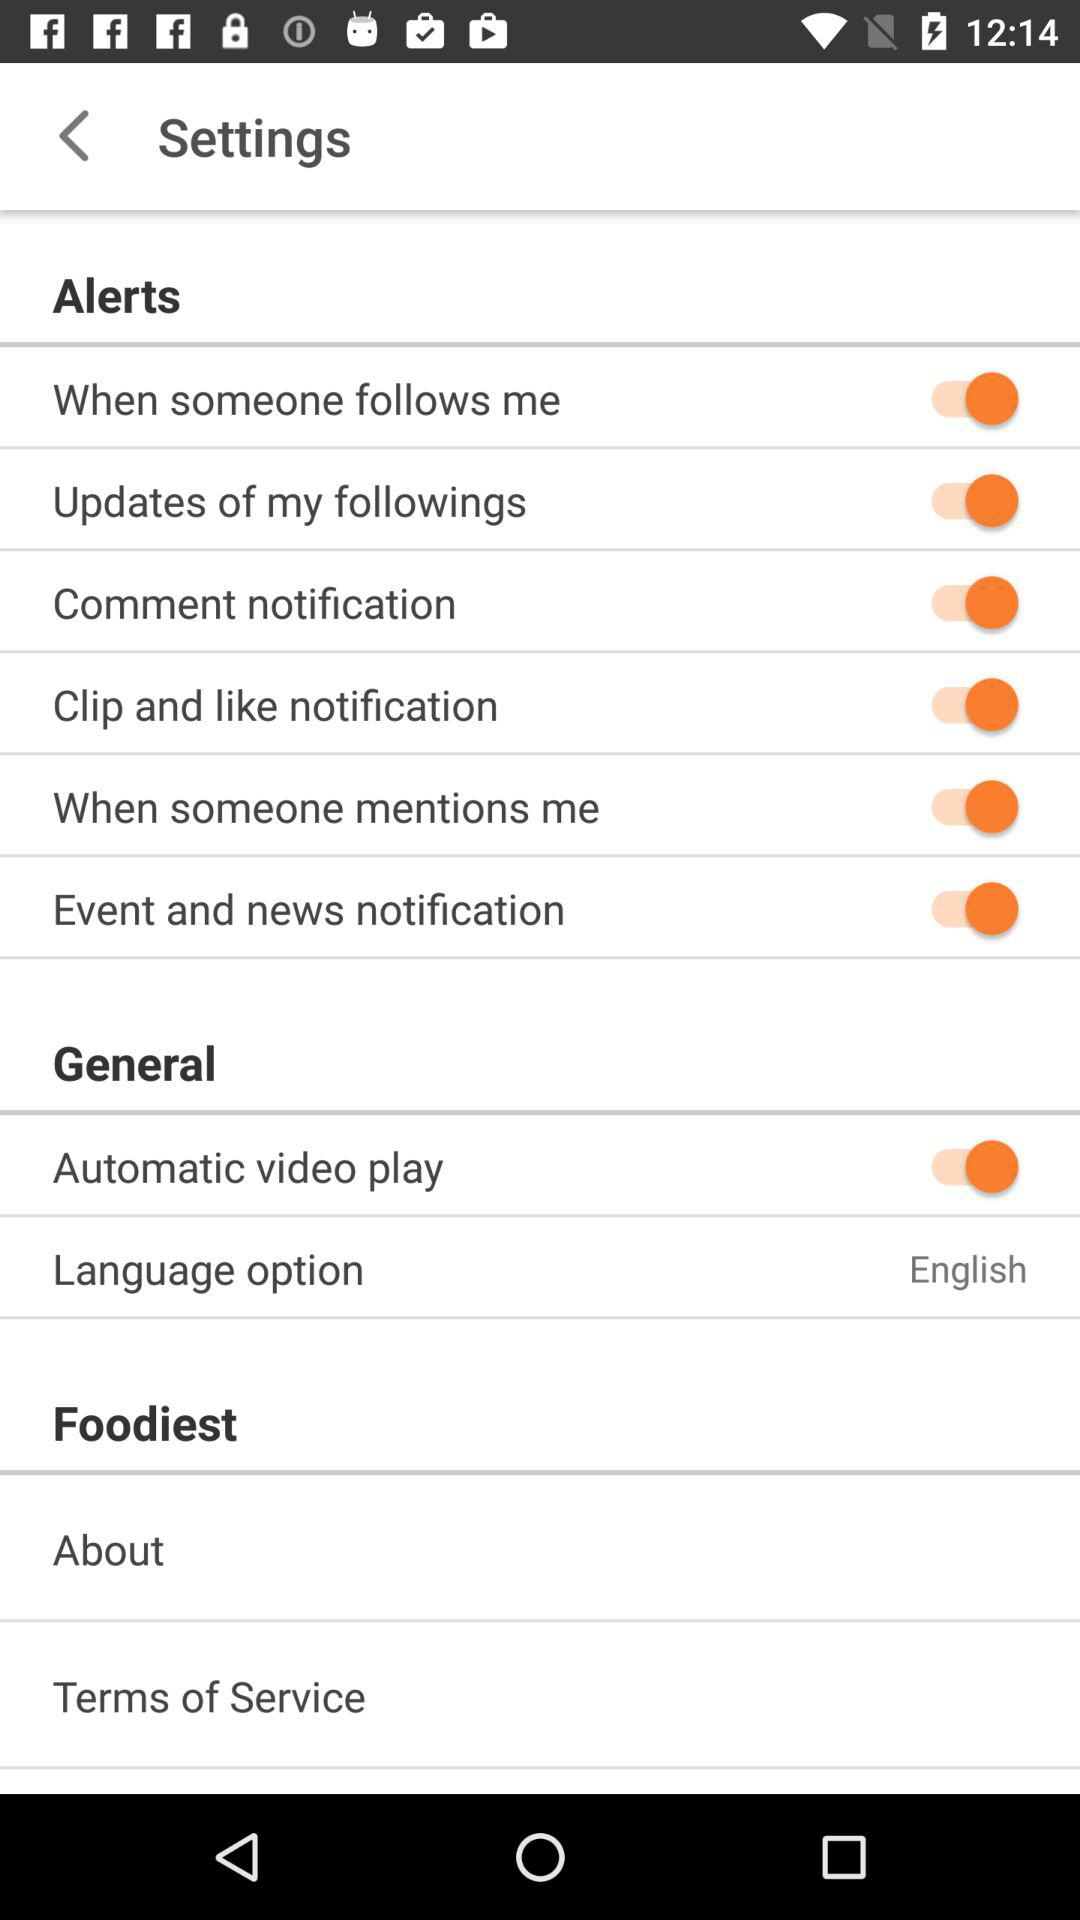What is the current status of "Clip and like notification"? The current status of "Clip and like notification" is "on". 